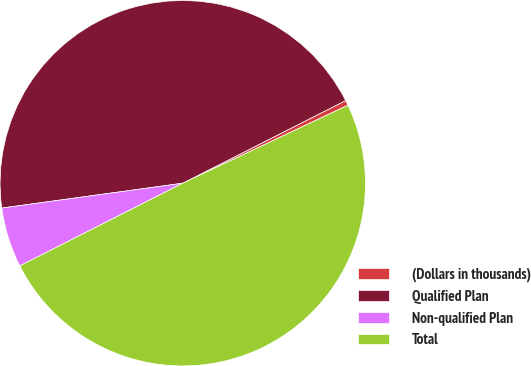Convert chart. <chart><loc_0><loc_0><loc_500><loc_500><pie_chart><fcel>(Dollars in thousands)<fcel>Qualified Plan<fcel>Non-qualified Plan<fcel>Total<nl><fcel>0.45%<fcel>44.7%<fcel>5.3%<fcel>49.55%<nl></chart> 